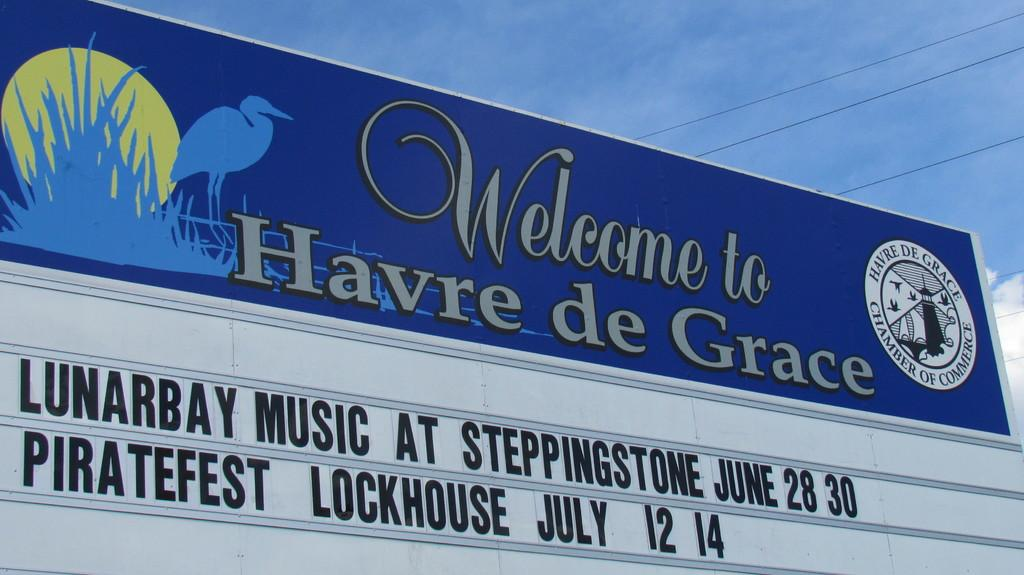<image>
Write a terse but informative summary of the picture. A sign with removable letters that reads Welcome to Havre de Grace. 